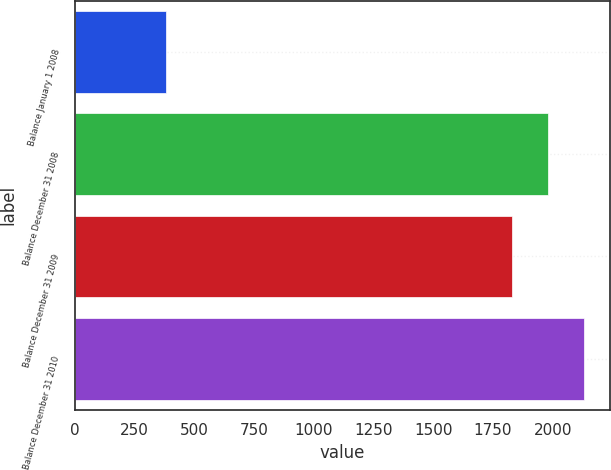<chart> <loc_0><loc_0><loc_500><loc_500><bar_chart><fcel>Balance January 1 2008<fcel>Balance December 31 2008<fcel>Balance December 31 2009<fcel>Balance December 31 2010<nl><fcel>384<fcel>1979.7<fcel>1828<fcel>2131.4<nl></chart> 